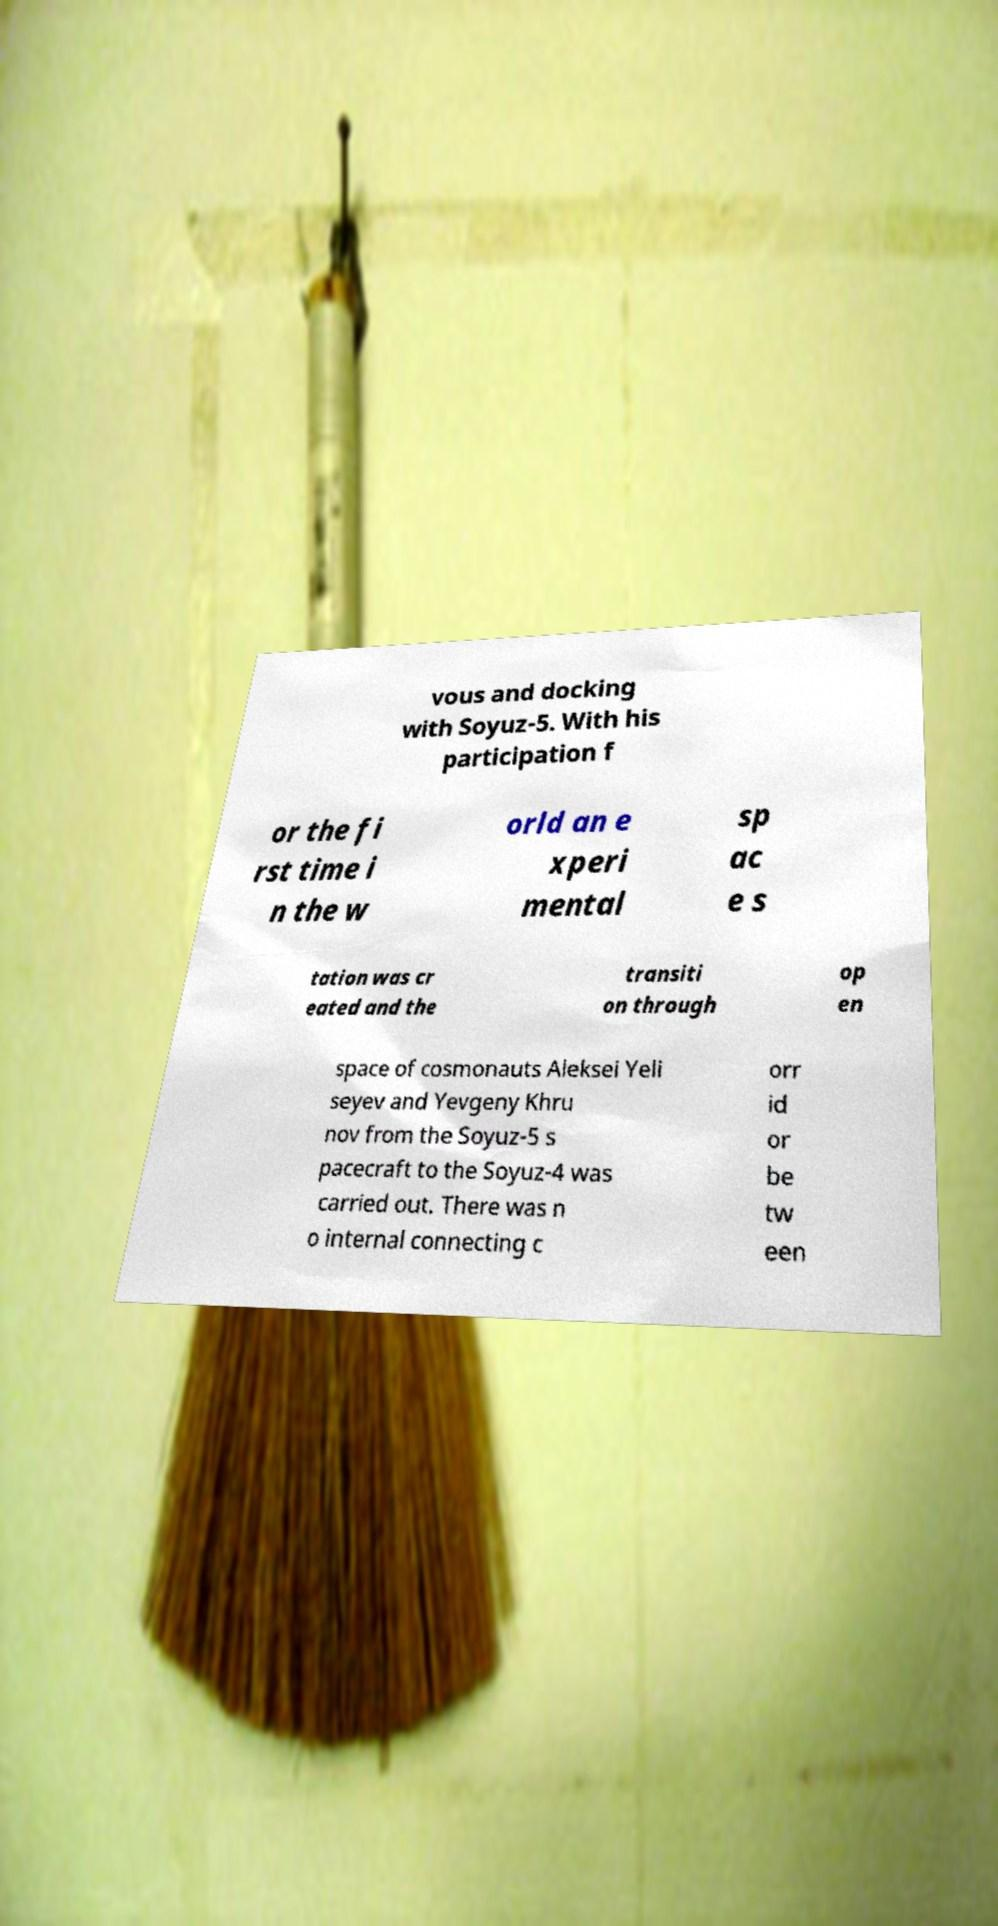Please identify and transcribe the text found in this image. vous and docking with Soyuz-5. With his participation f or the fi rst time i n the w orld an e xperi mental sp ac e s tation was cr eated and the transiti on through op en space of cosmonauts Aleksei Yeli seyev and Yevgeny Khru nov from the Soyuz-5 s pacecraft to the Soyuz-4 was carried out. There was n o internal connecting c orr id or be tw een 